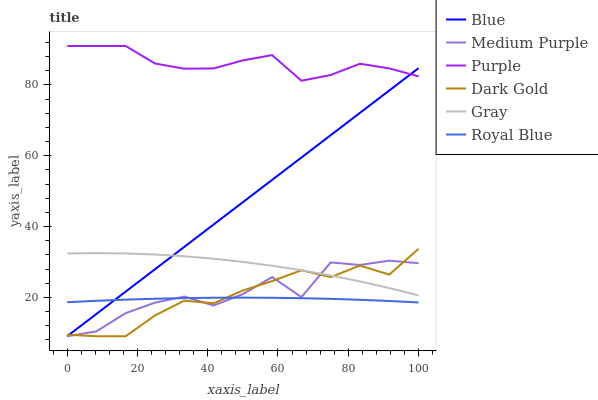Does Gray have the minimum area under the curve?
Answer yes or no. No. Does Gray have the maximum area under the curve?
Answer yes or no. No. Is Gray the smoothest?
Answer yes or no. No. Is Gray the roughest?
Answer yes or no. No. Does Gray have the lowest value?
Answer yes or no. No. Does Gray have the highest value?
Answer yes or no. No. Is Royal Blue less than Gray?
Answer yes or no. Yes. Is Purple greater than Dark Gold?
Answer yes or no. Yes. Does Royal Blue intersect Gray?
Answer yes or no. No. 